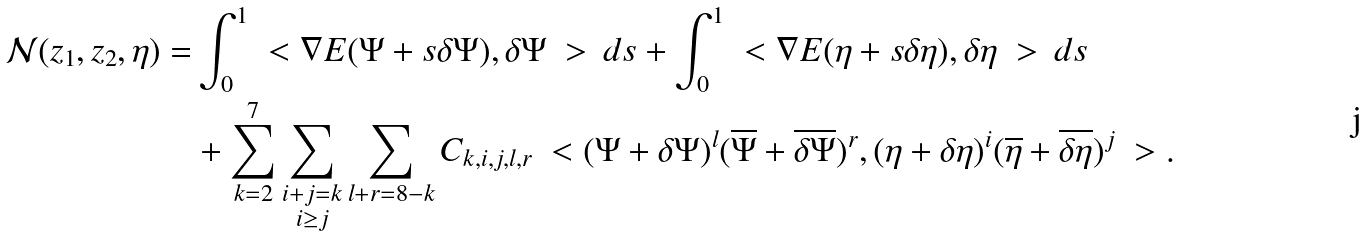Convert formula to latex. <formula><loc_0><loc_0><loc_500><loc_500>\mathcal { N } ( z _ { 1 } , z _ { 2 } , \eta ) = & \int _ { 0 } ^ { 1 } \ < \nabla E ( \Psi + s \delta \Psi ) , \delta \Psi \ > \, d s + \int _ { 0 } ^ { 1 } \ < \nabla E ( \eta + s \delta \eta ) , \delta \eta \ > \, d s \\ & + \sum _ { k = 2 } ^ { 7 } \sum _ { \substack { i + j = k \\ i \geq j } } \sum _ { l + r = 8 - k } C _ { k , i , j , l , r } \ < ( \Psi + \delta \Psi ) ^ { l } ( \overline { \Psi } + \overline { \delta \Psi } ) ^ { r } , ( \eta + \delta \eta ) ^ { i } ( \overline { \eta } + \overline { \delta \eta } ) ^ { j } \ > .</formula> 